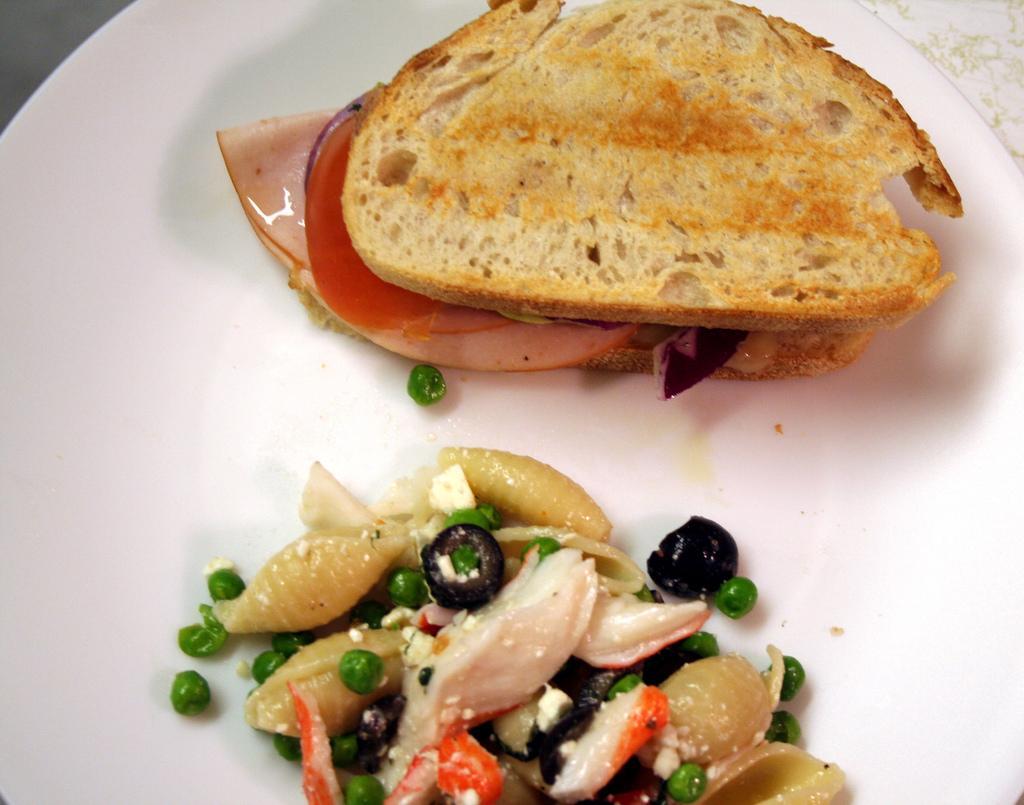Please provide a concise description of this image. In this picture we observe a salad and a toast in which there is bacon placed in it. 